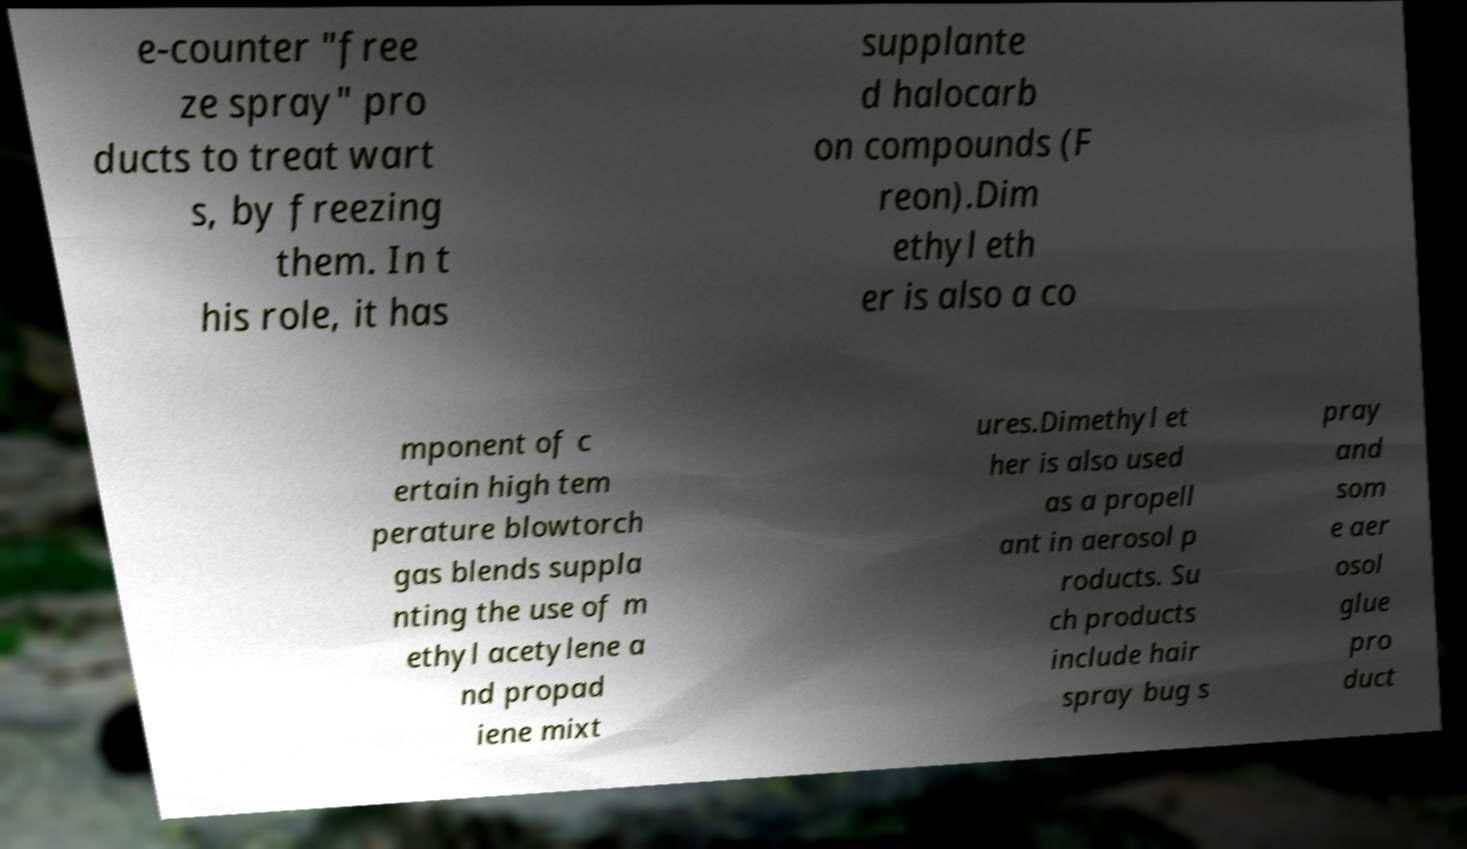I need the written content from this picture converted into text. Can you do that? e-counter "free ze spray" pro ducts to treat wart s, by freezing them. In t his role, it has supplante d halocarb on compounds (F reon).Dim ethyl eth er is also a co mponent of c ertain high tem perature blowtorch gas blends suppla nting the use of m ethyl acetylene a nd propad iene mixt ures.Dimethyl et her is also used as a propell ant in aerosol p roducts. Su ch products include hair spray bug s pray and som e aer osol glue pro duct 